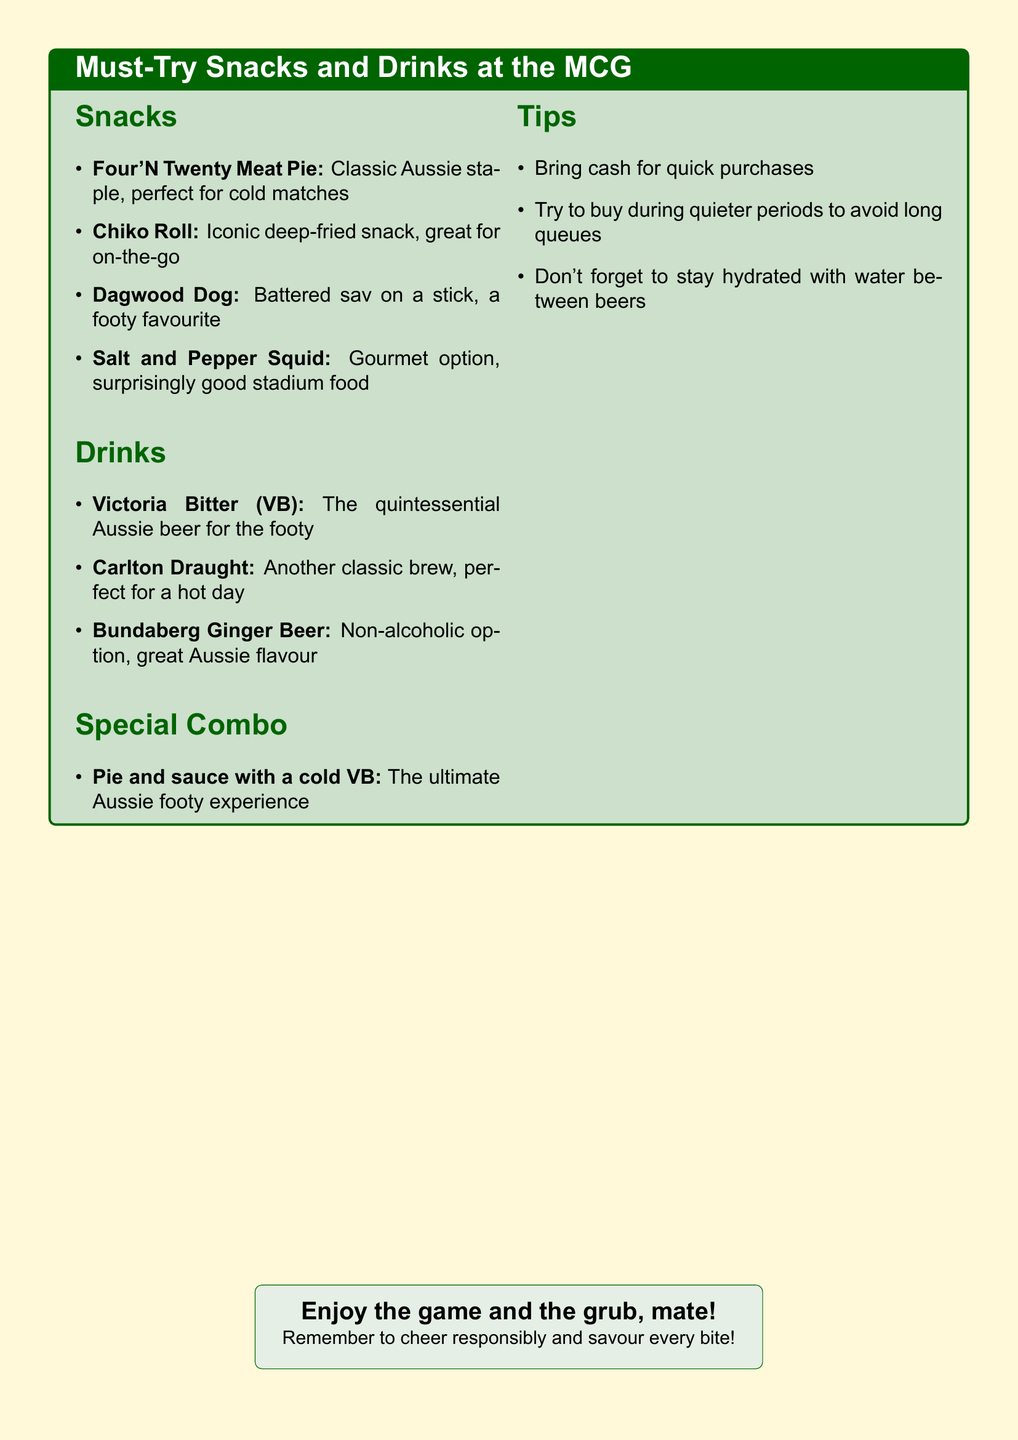What is the classic Aussie pie mentioned? The document refers to the Four'N Twenty Meat Pie as a classic Aussie pie.
Answer: Four'N Twenty Meat Pie What drink is described as the quintessential Aussie beer? The document notes Victoria Bitter (VB) as the quintessential Aussie beer.
Answer: Victoria Bitter (VB) What is a recommended non-alcoholic drink? The document lists Bundaberg Ginger Beer as a non-alcoholic option.
Answer: Bundaberg Ginger Beer Which snack is identified as surprisingly good stadium food? The document highlights Salt and Pepper Squid as a surprisingly good stadium food.
Answer: Salt and Pepper Squid What special combo is suggested for the ultimate footy experience? The document suggests the Pie and sauce with a cold VB as the ultimate experience.
Answer: Pie and sauce with a cold VB What is one tip for purchasing food at the stadium? The document advises bringing cash for quicker purchases as a tip.
Answer: Bring cash for quick purchases What is the main theme of the document? The document focuses on recommended snacks and drinks at the MCG.
Answer: Must-Try Snacks and Drinks How many different types of snacks are listed? There are four different types of snacks listed in the document.
Answer: Four What drink is best for a hot day according to the document? The document recommends Carlton Draught as perfect for a hot day.
Answer: Carlton Draught 